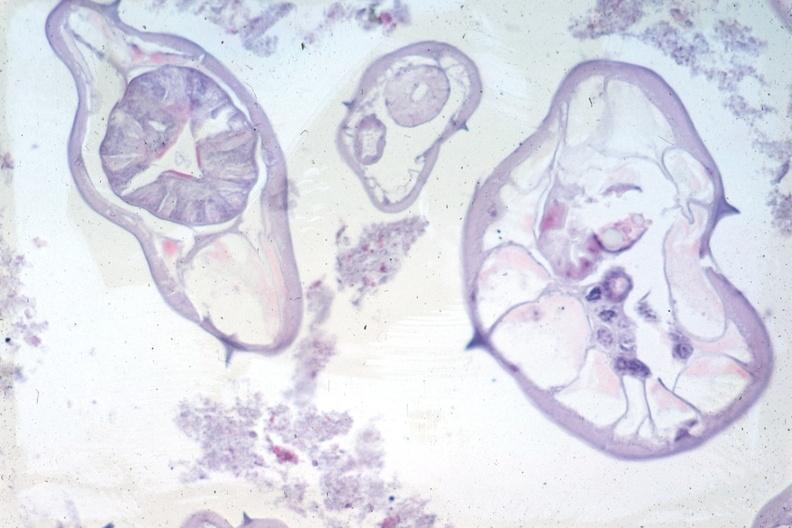what is present?
Answer the question using a single word or phrase. Pinworm 